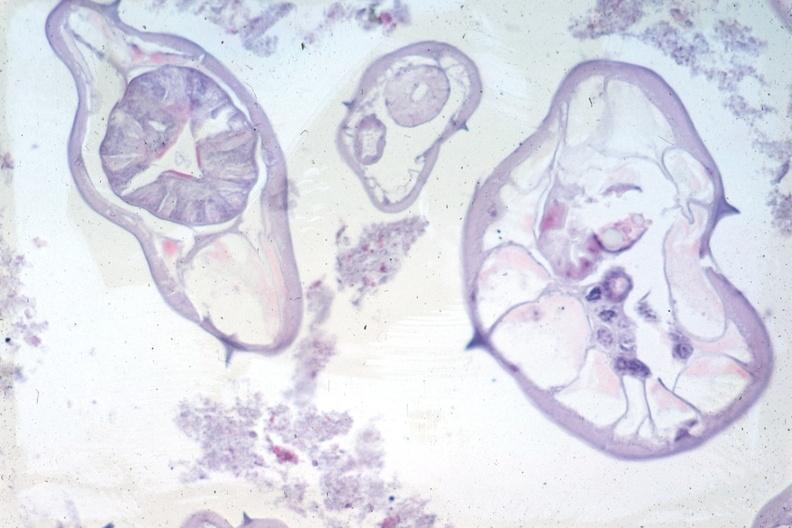what is present?
Answer the question using a single word or phrase. Pinworm 